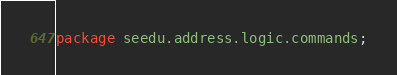Convert code to text. <code><loc_0><loc_0><loc_500><loc_500><_Java_>package seedu.address.logic.commands;
</code> 